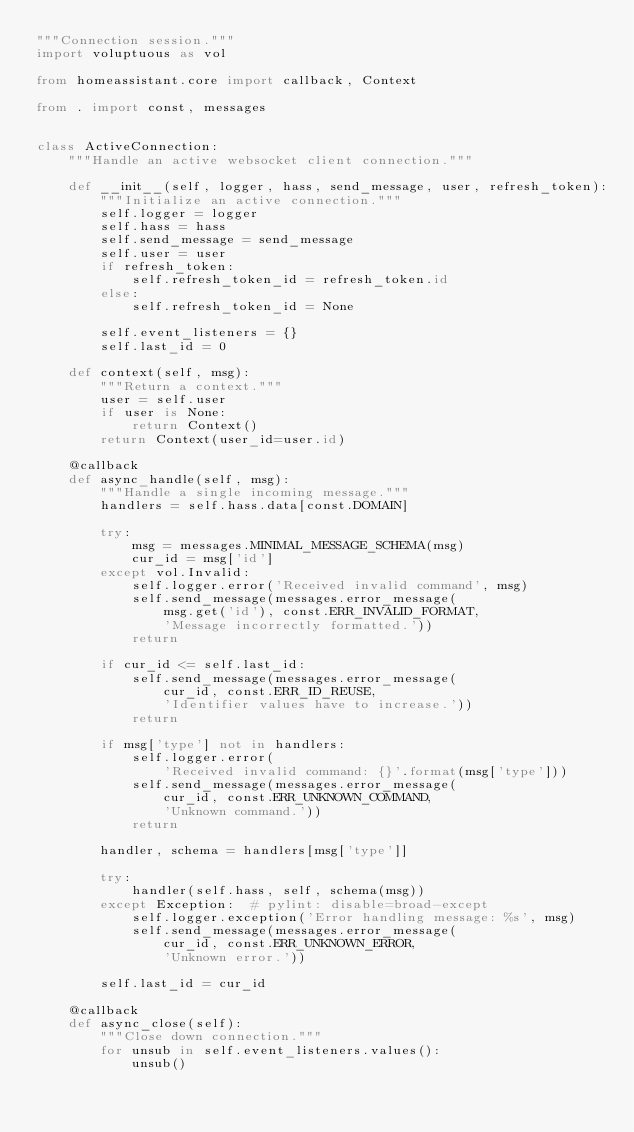<code> <loc_0><loc_0><loc_500><loc_500><_Python_>"""Connection session."""
import voluptuous as vol

from homeassistant.core import callback, Context

from . import const, messages


class ActiveConnection:
    """Handle an active websocket client connection."""

    def __init__(self, logger, hass, send_message, user, refresh_token):
        """Initialize an active connection."""
        self.logger = logger
        self.hass = hass
        self.send_message = send_message
        self.user = user
        if refresh_token:
            self.refresh_token_id = refresh_token.id
        else:
            self.refresh_token_id = None

        self.event_listeners = {}
        self.last_id = 0

    def context(self, msg):
        """Return a context."""
        user = self.user
        if user is None:
            return Context()
        return Context(user_id=user.id)

    @callback
    def async_handle(self, msg):
        """Handle a single incoming message."""
        handlers = self.hass.data[const.DOMAIN]

        try:
            msg = messages.MINIMAL_MESSAGE_SCHEMA(msg)
            cur_id = msg['id']
        except vol.Invalid:
            self.logger.error('Received invalid command', msg)
            self.send_message(messages.error_message(
                msg.get('id'), const.ERR_INVALID_FORMAT,
                'Message incorrectly formatted.'))
            return

        if cur_id <= self.last_id:
            self.send_message(messages.error_message(
                cur_id, const.ERR_ID_REUSE,
                'Identifier values have to increase.'))
            return

        if msg['type'] not in handlers:
            self.logger.error(
                'Received invalid command: {}'.format(msg['type']))
            self.send_message(messages.error_message(
                cur_id, const.ERR_UNKNOWN_COMMAND,
                'Unknown command.'))
            return

        handler, schema = handlers[msg['type']]

        try:
            handler(self.hass, self, schema(msg))
        except Exception:  # pylint: disable=broad-except
            self.logger.exception('Error handling message: %s', msg)
            self.send_message(messages.error_message(
                cur_id, const.ERR_UNKNOWN_ERROR,
                'Unknown error.'))

        self.last_id = cur_id

    @callback
    def async_close(self):
        """Close down connection."""
        for unsub in self.event_listeners.values():
            unsub()
</code> 